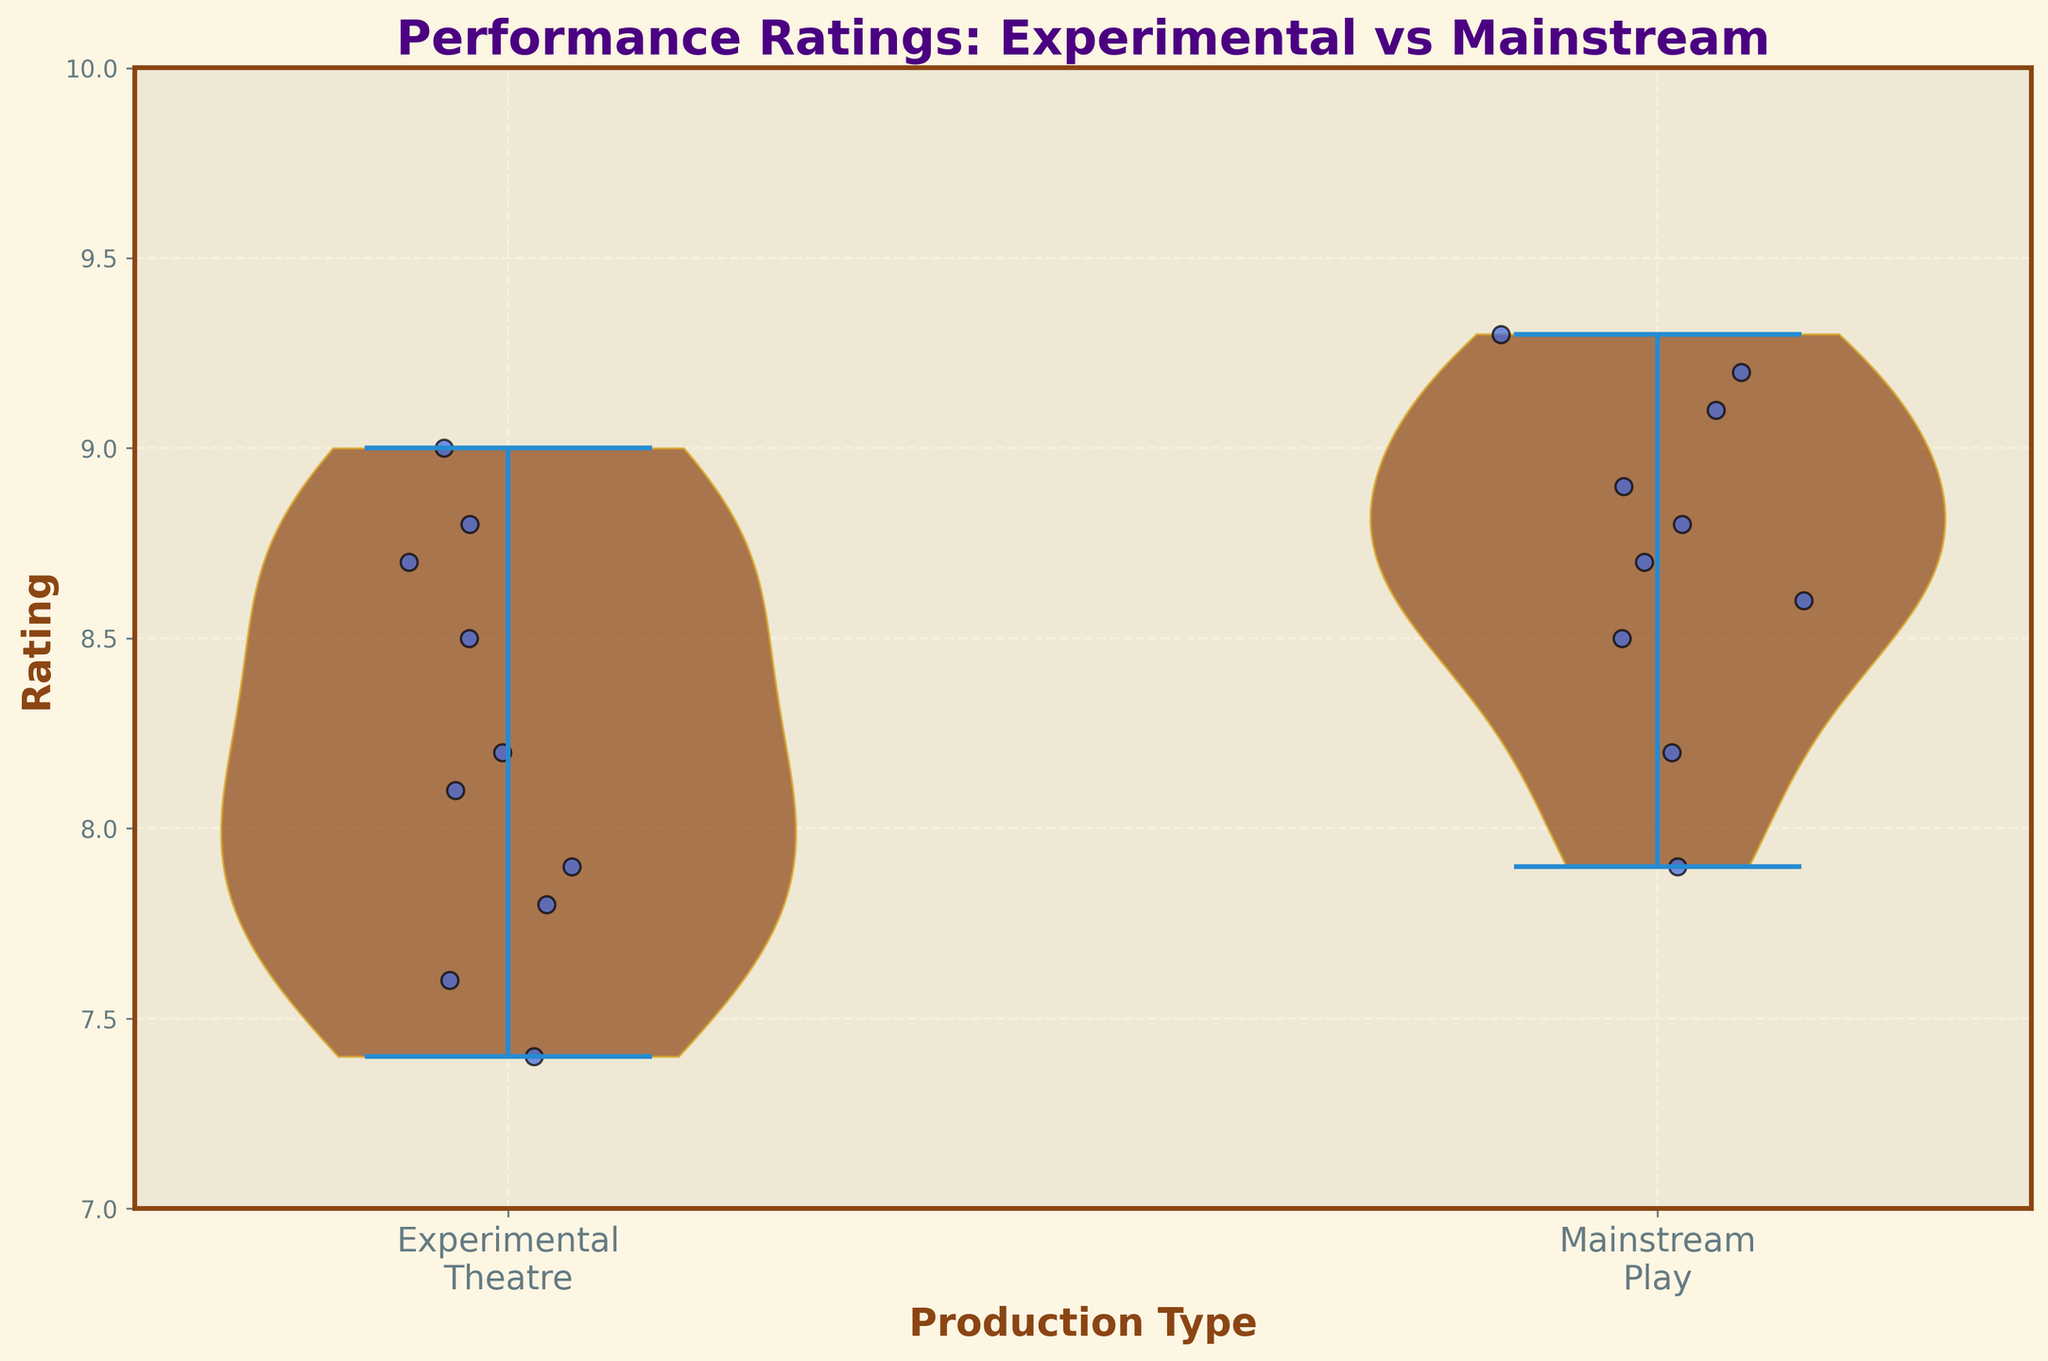What is the title of the figure? The title of the figure is usually displayed at the top. For this plot, it is "Performance Ratings: Experimental vs Mainstream".
Answer: Performance Ratings: Experimental vs Mainstream What are the types of productions compared in the figure? The x-axis labels show the production types compared in this figure: "Experimental Theatre" and "Mainstream Play".
Answer: Experimental Theatre and Mainstream Play What is the range of the y-axis ratings? The y-axis of the plot ranges from 7 to 10, as indicated by the axis labels and grid lines.
Answer: 7 to 10 Which production type has a higher median rating based on the violin plots? The median rating is visible as the thickest part of the violin plot. The mainstream plays show a higher median than the experimental theatre.
Answer: Mainstream Play How many individual data points are plotted for experimental theatre productions? By counting the jittered points on the experimental theatre side of the plot, we can see there are 10 individual points.
Answer: 10 What color are the jittered points in the figure? The jittered points in the figure are colored blue with a black edge.
Answer: Blue Which production has the highest rating in the dataset? From the jittered points and in conjunction with the y-axis, the highest rating visible is 9.3. This corresponds to "The Book of Mormon" listed in the main data.
Answer: The Book of Mormon How does the variability (spread) of ratings compare between experimental theatre and mainstream plays? The shape of the violin plots indicates variability. The experimental theatre shows a wider spread compared to mainstream plays, suggesting higher variability.
Answer: Experimental Theatre has higher variability What is a prominent feature of the violin plots in terms of color and style? The violin plots have a brownish fill with a golden edge, and they are semi-transparent to show the overlaying jittered points.
Answer: Brownish with golden edge Is there any overlap in the rating distributions between experimental theatre productions and mainstream plays? Yes, there is a noticeable overlap in the rating distributions where the violins intersect in the middle range (around 8 to 9).
Answer: Yes 